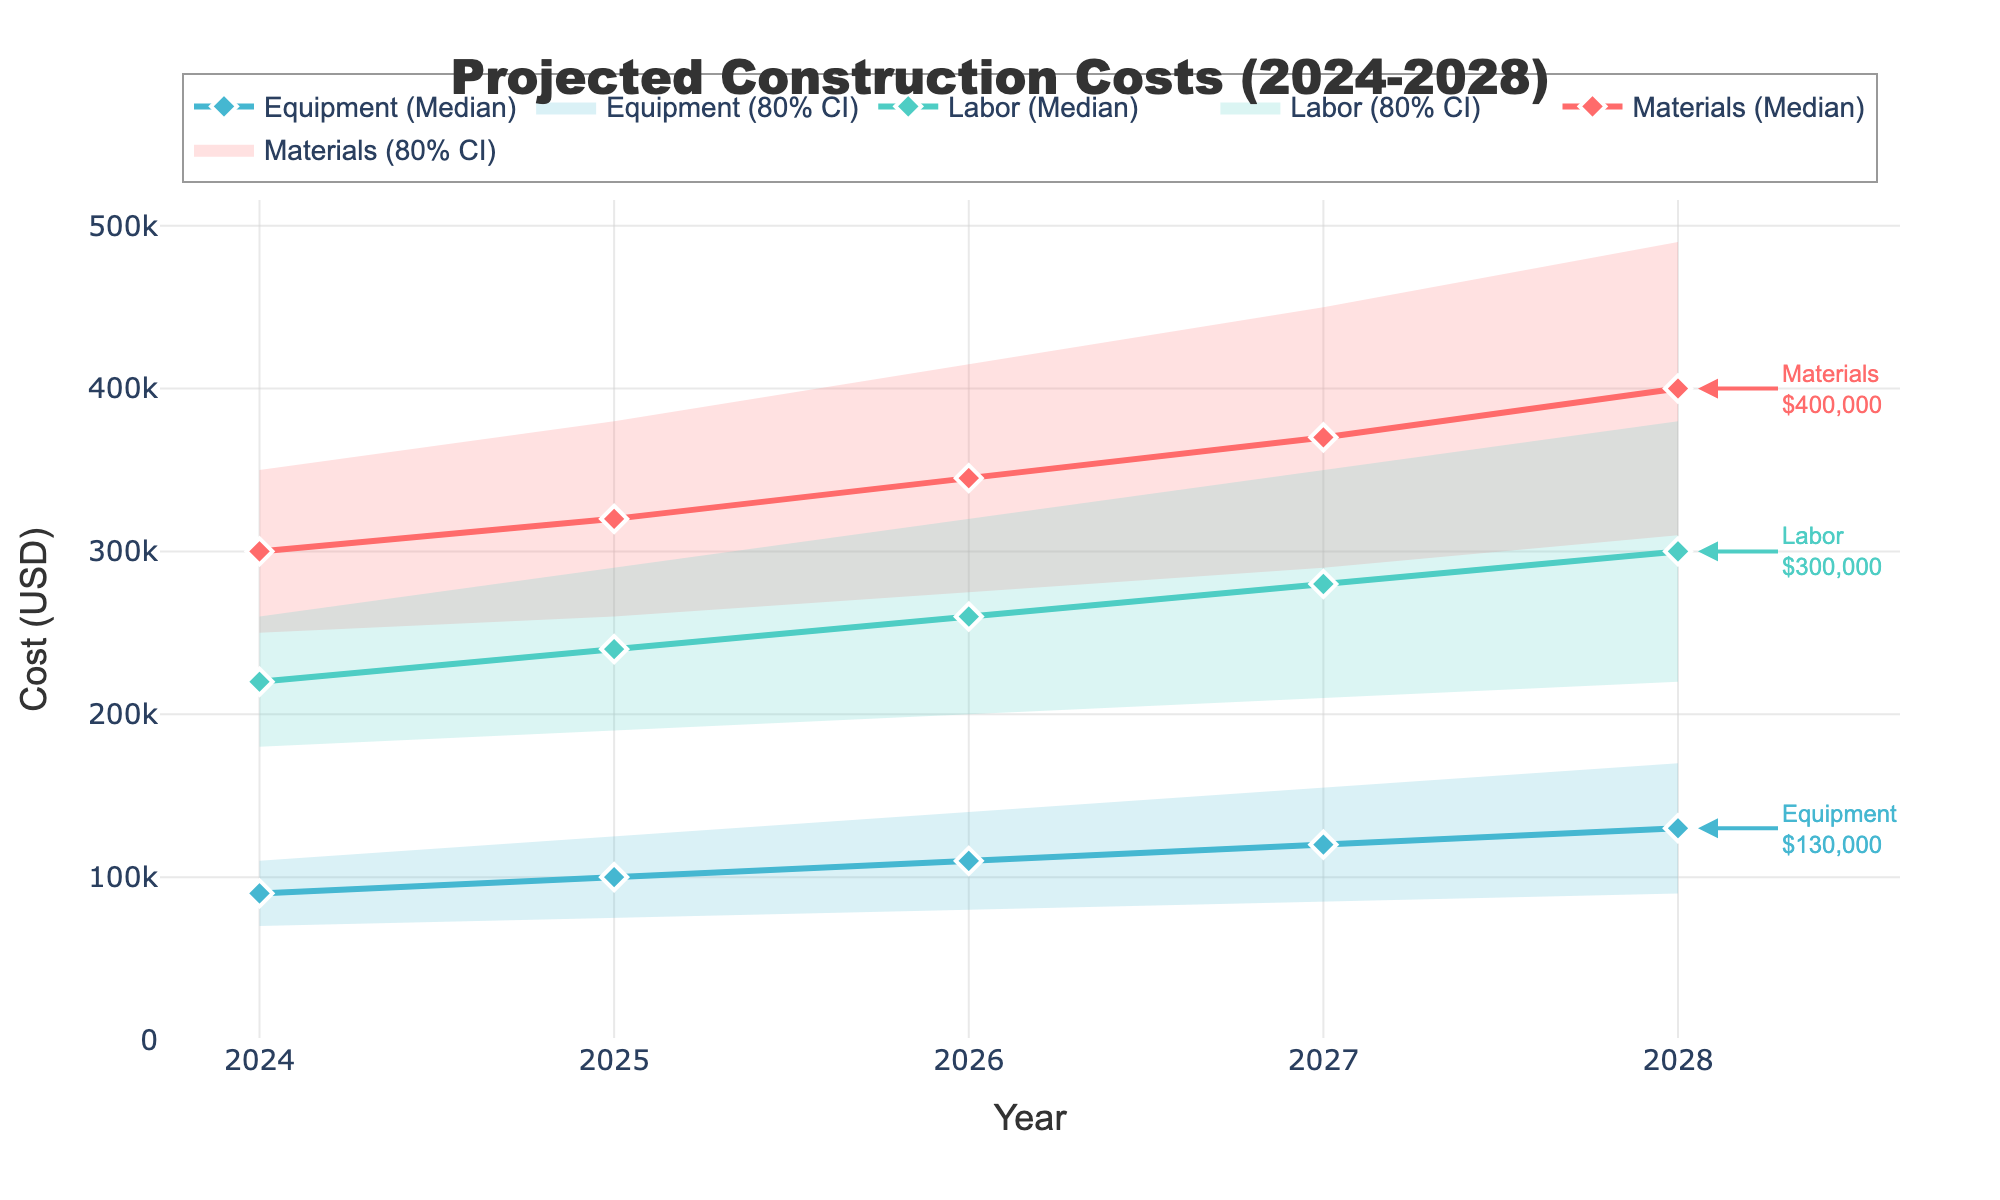What is the projected median cost for materials in the year 2028? Look at the line representing the median cost for materials in 2028. The marker or line position at 2028 indicates the value.
Answer: $400,000 Which category has the highest projected median cost in 2028? Compare the median lines for each category in the year 2028. The highest line indicates the category with the highest cost.
Answer: Materials What is the range of projected labor costs in 2025 (high value minus low value)? Subtract the low value for labor in 2025 from the high value in 2025: $290,000 - $190,000.
Answer: $100,000 How does the projected median equipment cost change from 2024 to 2028? Observe the change in the median line for equipment from 2024 to 2028. Specifically, note the values in 2024 and 2028 and find the difference: $130,000 - $90,000.
Answer: $40,000 In which year is the uncertainty (range between low and high values) the highest for materials costs? Calculate the range (high - low) for materials costs for each year and identify the year with the largest value. In 2028: $490,000 - $310,000 = $180,000.
Answer: 2028 Is the projected median cost for labor higher or lower than the projected median cost for equipment in 2026? Compare the median line value for labor and equipment in 2026: Labor ($260,000) and Equipment ($110,000).
Answer: Higher Which year shows the smallest projected median cost increase for materials compared to the previous year? Calculate the year-to-year differences in the median line for materials: 
2025-2024: $320,000 - $300,000 = $20,000 
2026-2025: $345,000 - $320,000 = $25,000 
2027-2026: $370,000 - $345,000 = $25,000 
2028-2027: $400,000 - $370,000 = $30,000
Answer: 2025 What is the projected median total cost for materials, labor, and equipment combined in 2027? Sum of median values for materials, labor, and equipment in 2027: 
Materials: $370,000 
Labor: $280,000 
Equipment: $120,000 
Total: $370,000 + $280,000 + $120,000
Answer: $770,000 Between which years does labor cost show the most significant median increase? Calculate the year-to-year differences in the median line for labor: 
2025-2024: $240,000 - $220,000 = $20,000 
2026-2025: $260,000 - $240,000 = $20,000 
2027-2026: $280,000 - $260,000 = $20,000 
2028-2027: $300,000 - $280,000 = $20,000
Answer: Each year shows a consistent $20,000 increase 